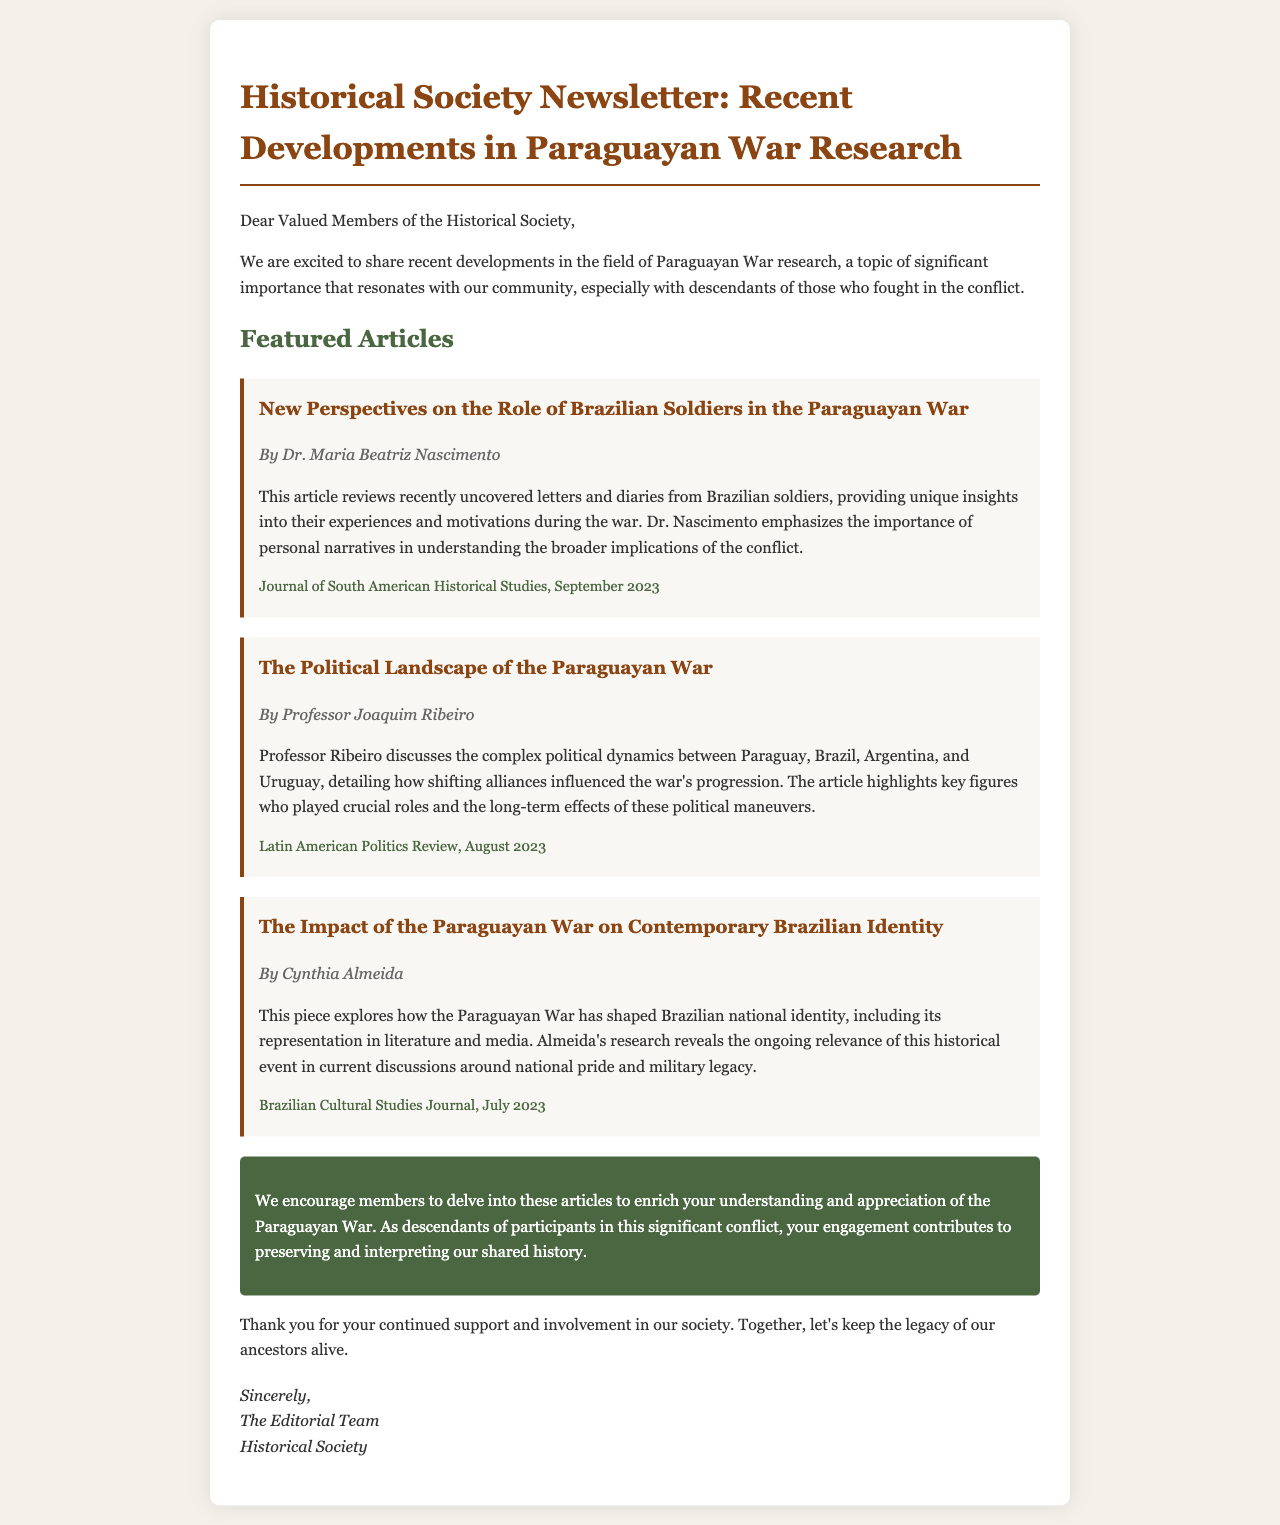What is the title of the newsletter? The title is prominently displayed at the top of the newsletter, which is "Historical Society Newsletter: Recent Developments in Paraguayan War Research."
Answer: Historical Society Newsletter: Recent Developments in Paraguayan War Research Who authored the article on Brazilian soldiers? The author's name is mentioned directly below the title of the article discussing Brazilian soldiers.
Answer: Dr. Maria Beatriz Nascimento What is the publication date of the article about political landscape? The publication date is listed at the end of the article, indicating when it was released.
Answer: August 2023 What organization published the article on Brazilian identity? The publication of this article is attributed to a specific journal mentioned underneath the title of the article.
Answer: Brazilian Cultural Studies Journal What type of content is emphasized in Dr. Nascimento's article? The article focuses on personal experiences and narratives related to Brazilian soldiers during the war.
Answer: Personal narratives What action does the newsletter encourage members to take? The newsletter contains a call-to-action that urges members to engage with the articles for a better understanding.
Answer: Delve into these articles How many articles are featured in the newsletter? The number of articles can be counted based on the sections outlined in the newsletter.
Answer: Three articles What color is the background of the newsletter? The background color is described in the style section of the document.
Answer: #f4f1ea 